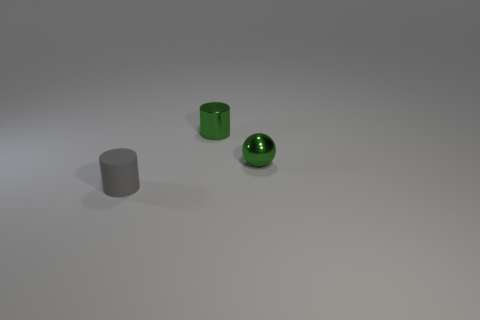Add 3 green objects. How many objects exist? 6 Subtract all balls. How many objects are left? 2 Subtract 0 yellow balls. How many objects are left? 3 Subtract all green metal spheres. Subtract all large yellow metallic blocks. How many objects are left? 2 Add 2 tiny matte cylinders. How many tiny matte cylinders are left? 3 Add 2 rubber objects. How many rubber objects exist? 3 